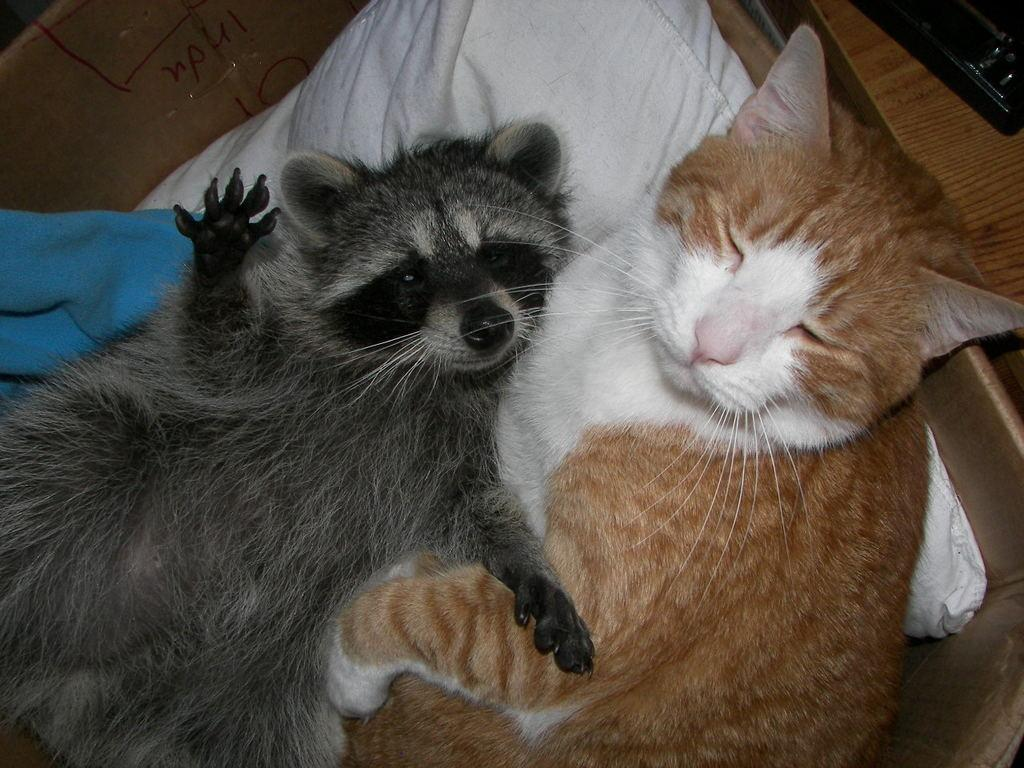What type of animal can be seen in the image? There is a cat in the image. Are there any other animals present in the image? Yes, there is another animal in the image. What are the animals doing in the image? Both animals are laying on a pillow. What type of event is happening in the image? There is no specific event happening in the image; it simply shows two animals laying on a pillow. Can you tell me the exact spot where the cat is laying on the pillow? The exact spot where the cat is laying on the pillow cannot be determined from the image alone, as the focus is on the animals and not their precise location on the pillow. 